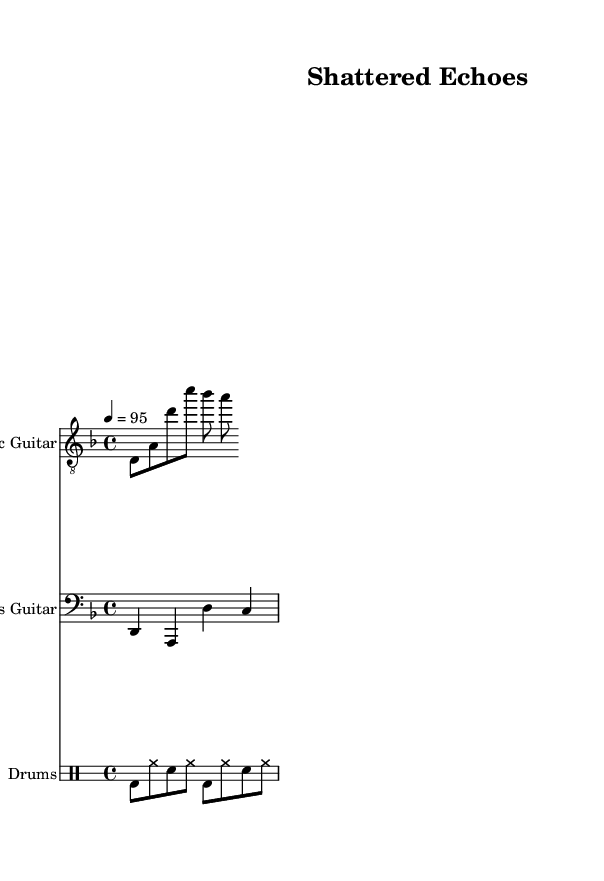What key is this music in? The key signature is indicated by the sharp or flat notes at the beginning of the staff. Here, the presence of a B flat indicates that it is in D minor.
Answer: D minor What is the time signature? The time signature is located at the beginning of the staff and appears in the form of a fraction. Here, it shows 4/4, which means there are four beats per measure.
Answer: 4/4 What is the tempo marking? The tempo marking is indicated by the number and the equals sign, which shows the beats per minute. In this case, it is marked as 4 = 95, meaning there are 95 beats per minute.
Answer: 95 How many measures are in the guitar part? By counting the number of vertical lines (bar lines) that separate the measures in the guitar part, we can determine the number of measures. In this case, there are three measures shown.
Answer: 3 What instrument has the clef labeled "bass"? The clef labeled "bass" is specifically associated with the bass part located in the lower staff section. This indicates that the bass guitar is the instrument playing this part.
Answer: Bass Guitar What rhythm pattern is used for the drums? The drum pattern can be identified by the notational symbols within the drum staff. The sequence clearly shows a mix of bass drum and snare hits along with hi-hat notes, indicating a rock-style rhythm often used in nu metal.
Answer: Rock-style rhythm Which part likely conveys angst through lyrics? While the sheet music itself does not contain lyrics, the overall context of nu metal music, known for its angsty themes, suggests that the vocal part—often emphasized alongside heavy riffs—would provide the lyrics expressing angst.
Answer: Vocal part 